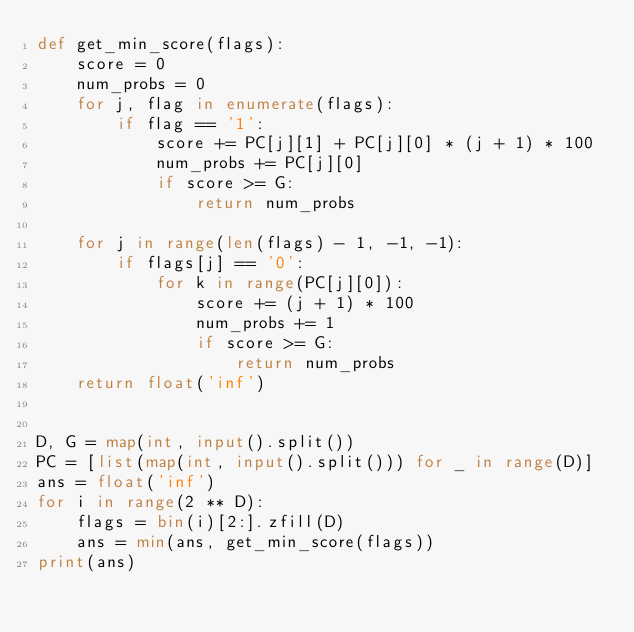<code> <loc_0><loc_0><loc_500><loc_500><_Python_>def get_min_score(flags):
    score = 0
    num_probs = 0
    for j, flag in enumerate(flags):
        if flag == '1':
            score += PC[j][1] + PC[j][0] * (j + 1) * 100
            num_probs += PC[j][0]
            if score >= G:
                return num_probs

    for j in range(len(flags) - 1, -1, -1):
        if flags[j] == '0':
            for k in range(PC[j][0]):
                score += (j + 1) * 100
                num_probs += 1
                if score >= G:
                    return num_probs
    return float('inf')


D, G = map(int, input().split())
PC = [list(map(int, input().split())) for _ in range(D)]
ans = float('inf')
for i in range(2 ** D):
    flags = bin(i)[2:].zfill(D)
    ans = min(ans, get_min_score(flags))
print(ans)
</code> 